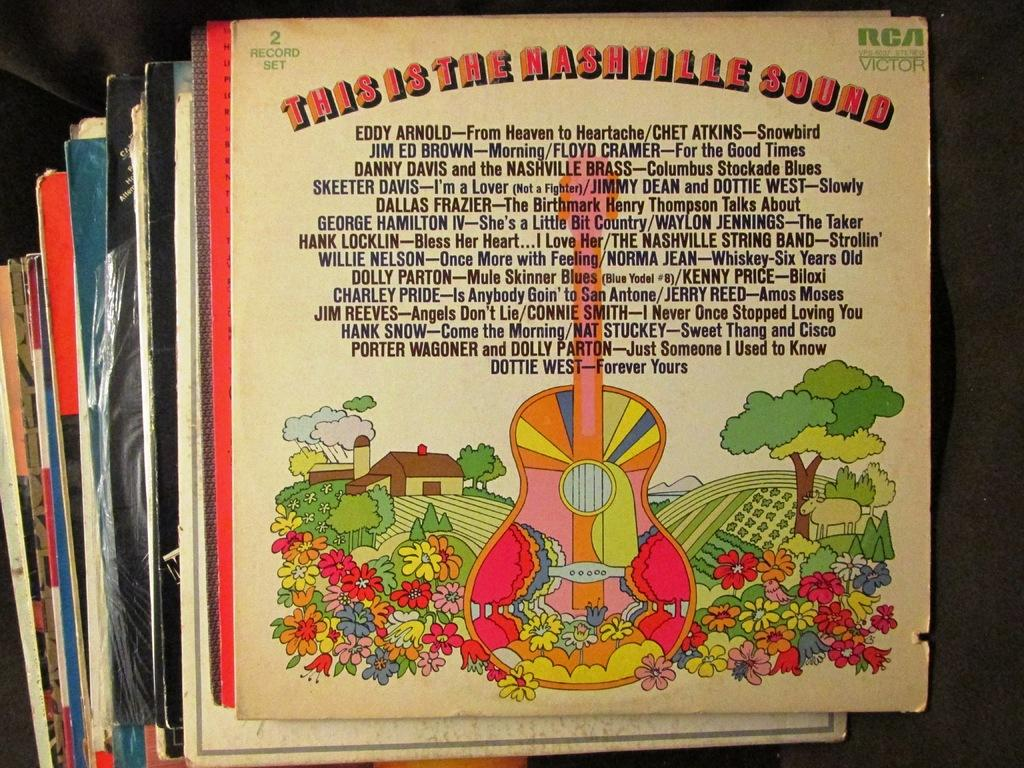<image>
Present a compact description of the photo's key features. The album This is the Nashville Sound has a multi-colored guitar on its cover. 